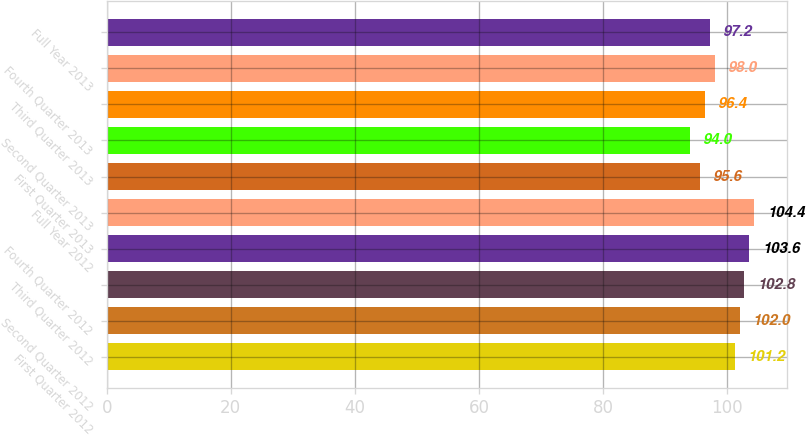Convert chart. <chart><loc_0><loc_0><loc_500><loc_500><bar_chart><fcel>First Quarter 2012<fcel>Second Quarter 2012<fcel>Third Quarter 2012<fcel>Fourth Quarter 2012<fcel>Full Year 2012<fcel>First Quarter 2013<fcel>Second Quarter 2013<fcel>Third Quarter 2013<fcel>Fourth Quarter 2013<fcel>Full Year 2013<nl><fcel>101.2<fcel>102<fcel>102.8<fcel>103.6<fcel>104.4<fcel>95.6<fcel>94<fcel>96.4<fcel>98<fcel>97.2<nl></chart> 